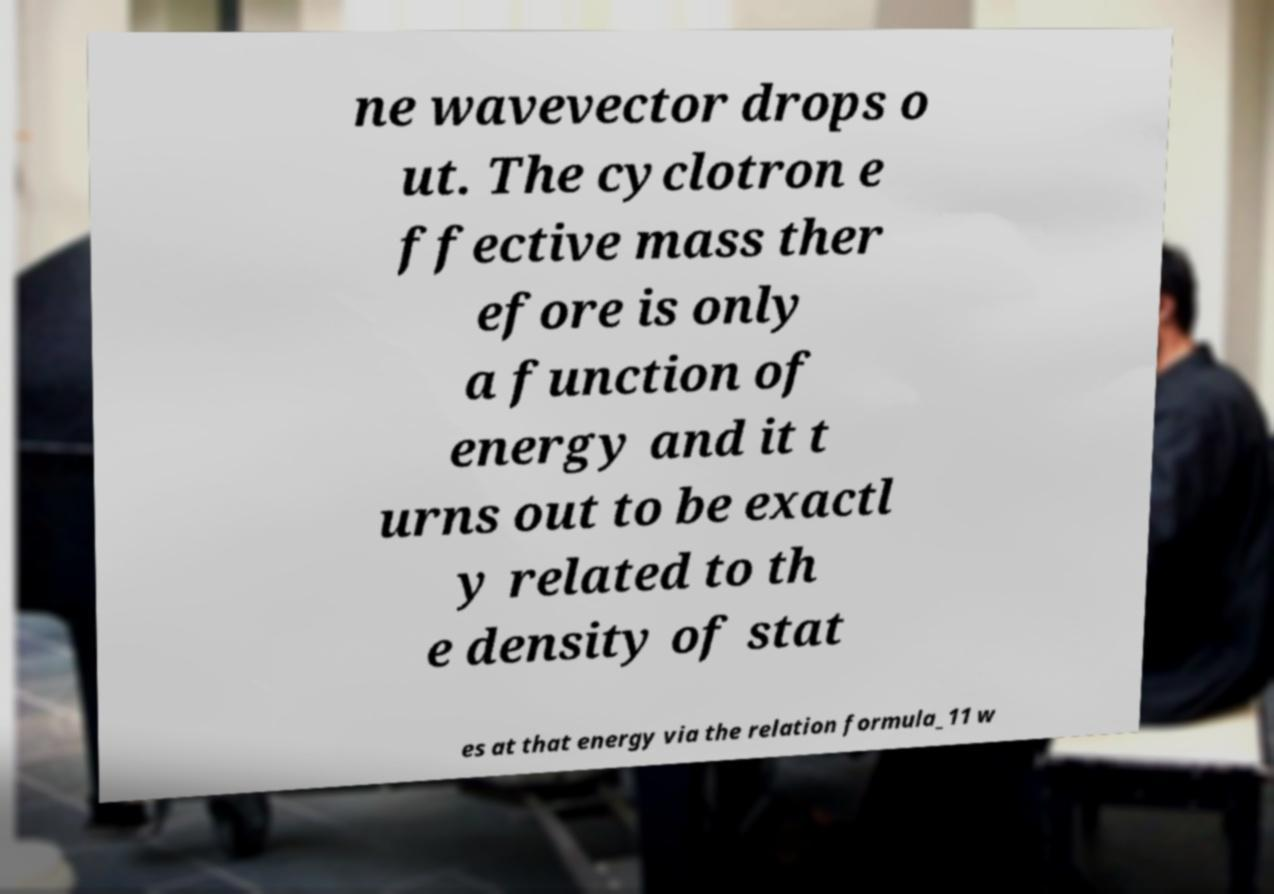Could you extract and type out the text from this image? ne wavevector drops o ut. The cyclotron e ffective mass ther efore is only a function of energy and it t urns out to be exactl y related to th e density of stat es at that energy via the relation formula_11 w 